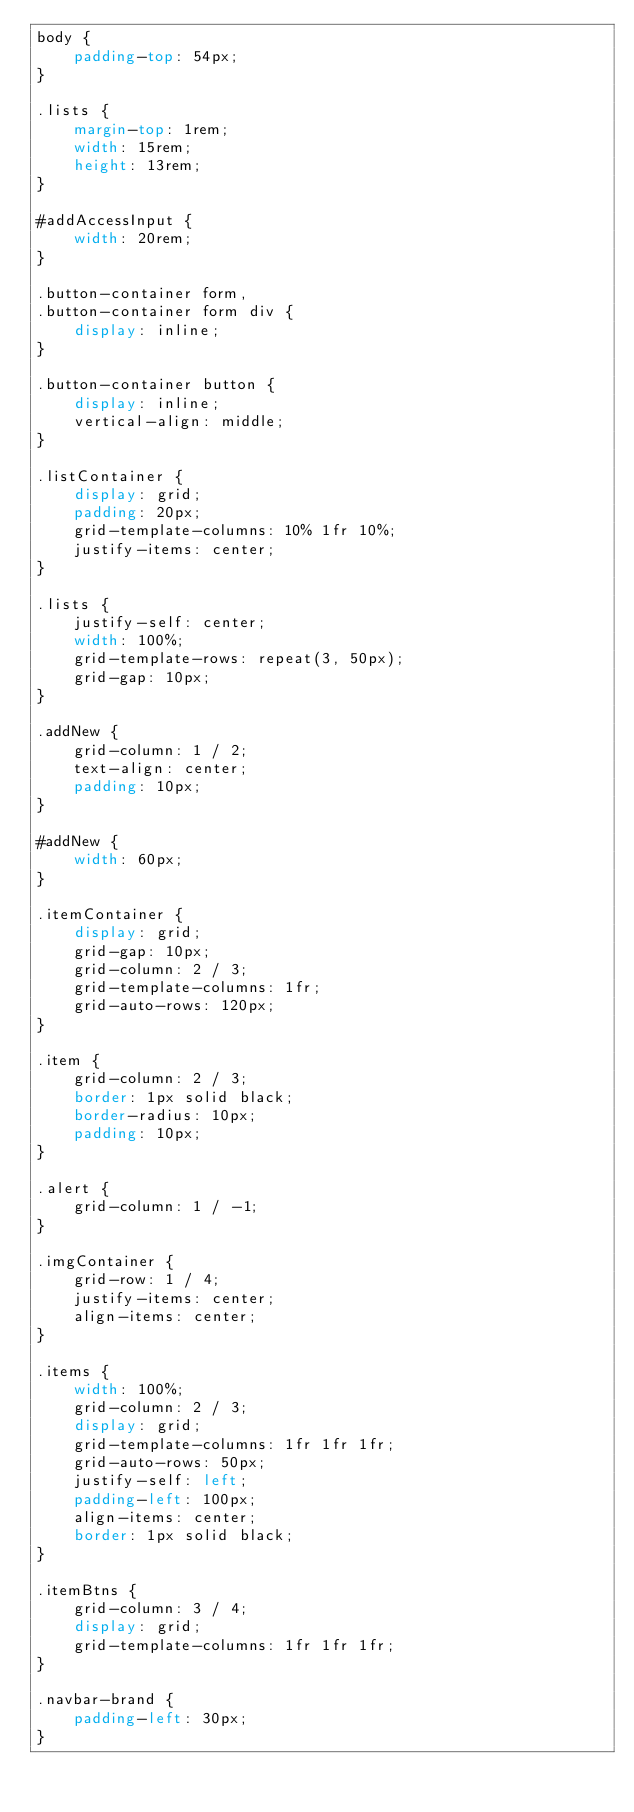Convert code to text. <code><loc_0><loc_0><loc_500><loc_500><_CSS_>body {
    padding-top: 54px;
}

.lists {
    margin-top: 1rem;
    width: 15rem; 
    height: 13rem;
}

#addAccessInput {
    width: 20rem;
}

.button-container form,
.button-container form div {
    display: inline;
}

.button-container button {
    display: inline;
    vertical-align: middle;
}

.listContainer {
    display: grid;
    padding: 20px;
    grid-template-columns: 10% 1fr 10%;
    justify-items: center;
}

.lists {
    justify-self: center;
    width: 100%;
    grid-template-rows: repeat(3, 50px);
    grid-gap: 10px;
}

.addNew {
    grid-column: 1 / 2;
    text-align: center;
    padding: 10px;
}

#addNew {
    width: 60px;
}

.itemContainer {
    display: grid;
    grid-gap: 10px;
    grid-column: 2 / 3;
    grid-template-columns: 1fr;
    grid-auto-rows: 120px;  
}

.item {
    grid-column: 2 / 3;
    border: 1px solid black;
    border-radius: 10px;
    padding: 10px;
}

.alert {
    grid-column: 1 / -1;
}

.imgContainer {
    grid-row: 1 / 4;
    justify-items: center;
    align-items: center;   
}

.items {
    width: 100%;
    grid-column: 2 / 3;
    display: grid;
    grid-template-columns: 1fr 1fr 1fr;
    grid-auto-rows: 50px;
    justify-self: left;
    padding-left: 100px;
    align-items: center;
    border: 1px solid black;
}

.itemBtns {
    grid-column: 3 / 4;
    display: grid;
    grid-template-columns: 1fr 1fr 1fr;
}

.navbar-brand {
    padding-left: 30px;
}</code> 